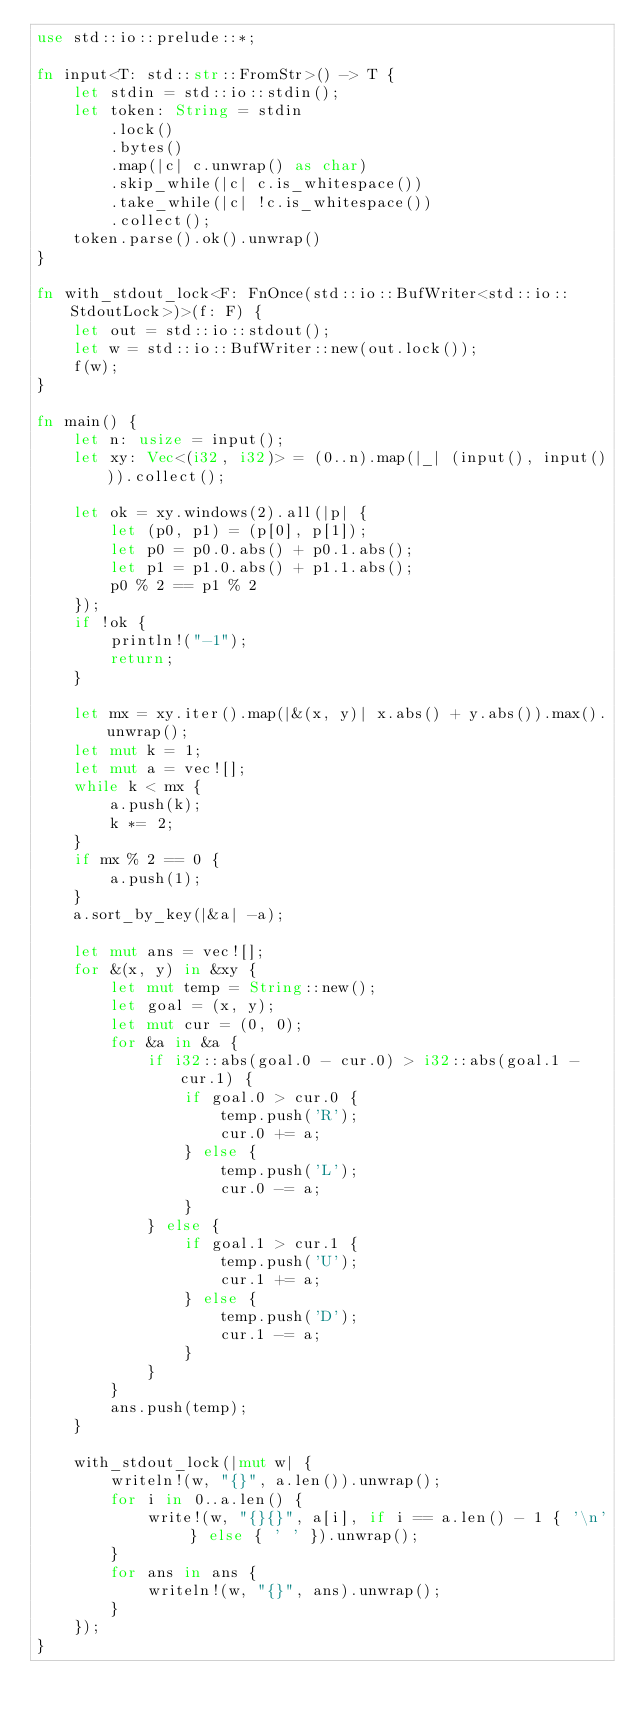Convert code to text. <code><loc_0><loc_0><loc_500><loc_500><_Rust_>use std::io::prelude::*;

fn input<T: std::str::FromStr>() -> T {
    let stdin = std::io::stdin();
    let token: String = stdin
        .lock()
        .bytes()
        .map(|c| c.unwrap() as char)
        .skip_while(|c| c.is_whitespace())
        .take_while(|c| !c.is_whitespace())
        .collect();
    token.parse().ok().unwrap()
}

fn with_stdout_lock<F: FnOnce(std::io::BufWriter<std::io::StdoutLock>)>(f: F) {
    let out = std::io::stdout();
    let w = std::io::BufWriter::new(out.lock());
    f(w);
}

fn main() {
    let n: usize = input();
    let xy: Vec<(i32, i32)> = (0..n).map(|_| (input(), input())).collect();

    let ok = xy.windows(2).all(|p| {
        let (p0, p1) = (p[0], p[1]);
        let p0 = p0.0.abs() + p0.1.abs();
        let p1 = p1.0.abs() + p1.1.abs();
        p0 % 2 == p1 % 2
    });
    if !ok {
        println!("-1");
        return;
    }

    let mx = xy.iter().map(|&(x, y)| x.abs() + y.abs()).max().unwrap();
    let mut k = 1;
    let mut a = vec![];
    while k < mx {
        a.push(k);
        k *= 2;
    }
    if mx % 2 == 0 {
        a.push(1);
    }
    a.sort_by_key(|&a| -a);

    let mut ans = vec![];
    for &(x, y) in &xy {
        let mut temp = String::new();
        let goal = (x, y);
        let mut cur = (0, 0);
        for &a in &a {
            if i32::abs(goal.0 - cur.0) > i32::abs(goal.1 - cur.1) {
                if goal.0 > cur.0 {
                    temp.push('R');
                    cur.0 += a;
                } else {
                    temp.push('L');
                    cur.0 -= a;
                }
            } else {
                if goal.1 > cur.1 {
                    temp.push('U');
                    cur.1 += a;
                } else {
                    temp.push('D');
                    cur.1 -= a;
                }
            }
        }
        ans.push(temp);
    }

    with_stdout_lock(|mut w| {
        writeln!(w, "{}", a.len()).unwrap();
        for i in 0..a.len() {
            write!(w, "{}{}", a[i], if i == a.len() - 1 { '\n' } else { ' ' }).unwrap();
        }
        for ans in ans {
            writeln!(w, "{}", ans).unwrap();
        }
    });
}
</code> 